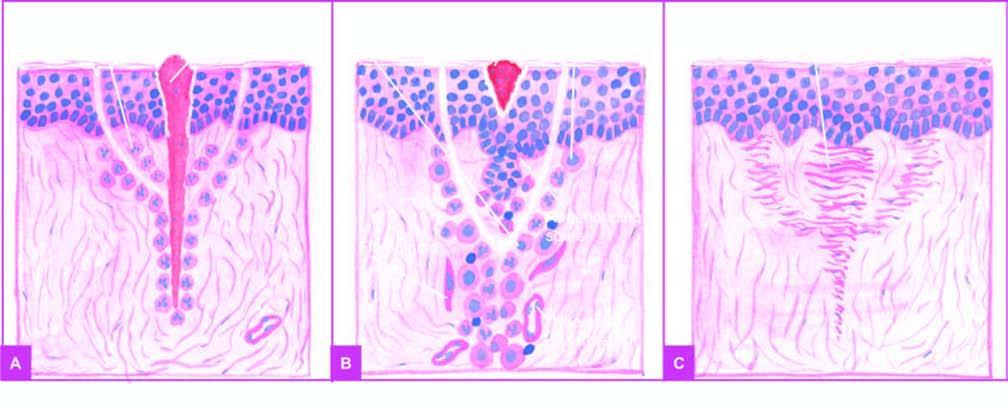what are filled with blood clot?
Answer the question using a single word or phrase. The open wound 